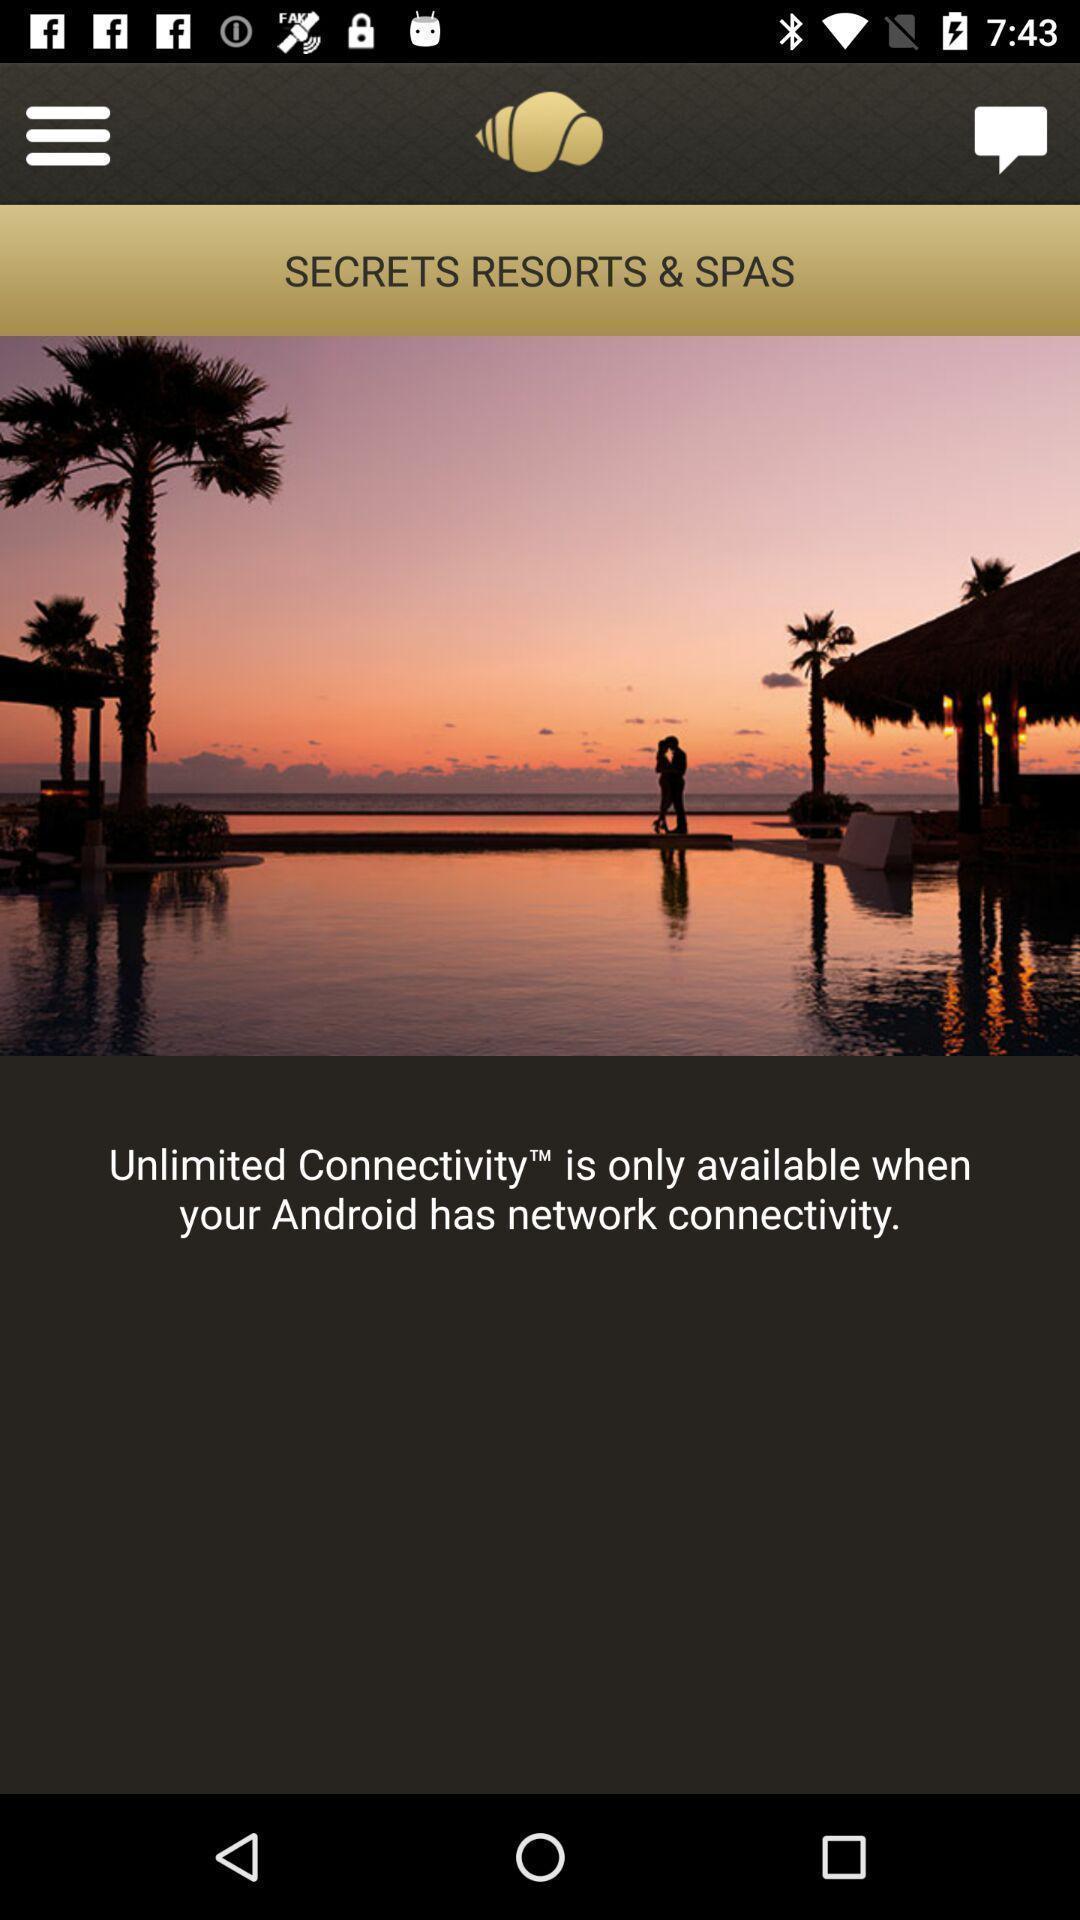Explain what's happening in this screen capture. Welcome page of a resorts booking app. 